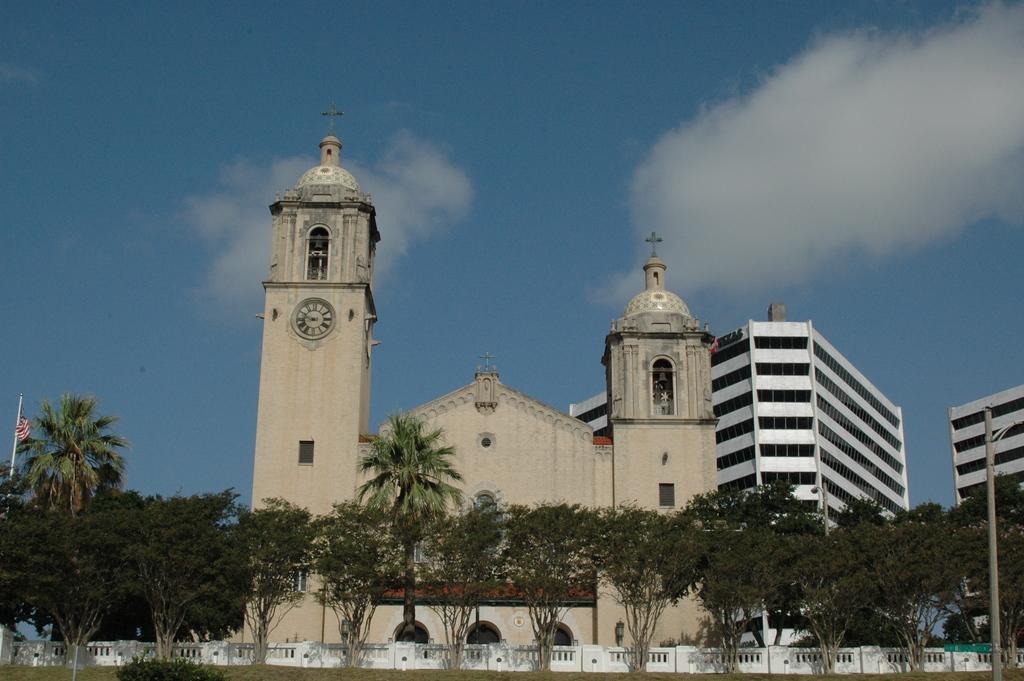Could you give a brief overview of what you see in this image? This image is taken outdoors. At the top of the image there is a sky with clouds. At the bottom of the image there is a ground with grass and a plant. In the middle of the image there are many trees, a pole, a flag and a few buildings with walls, windows, doors, balconies and railings and there is a clock on the church wall. 